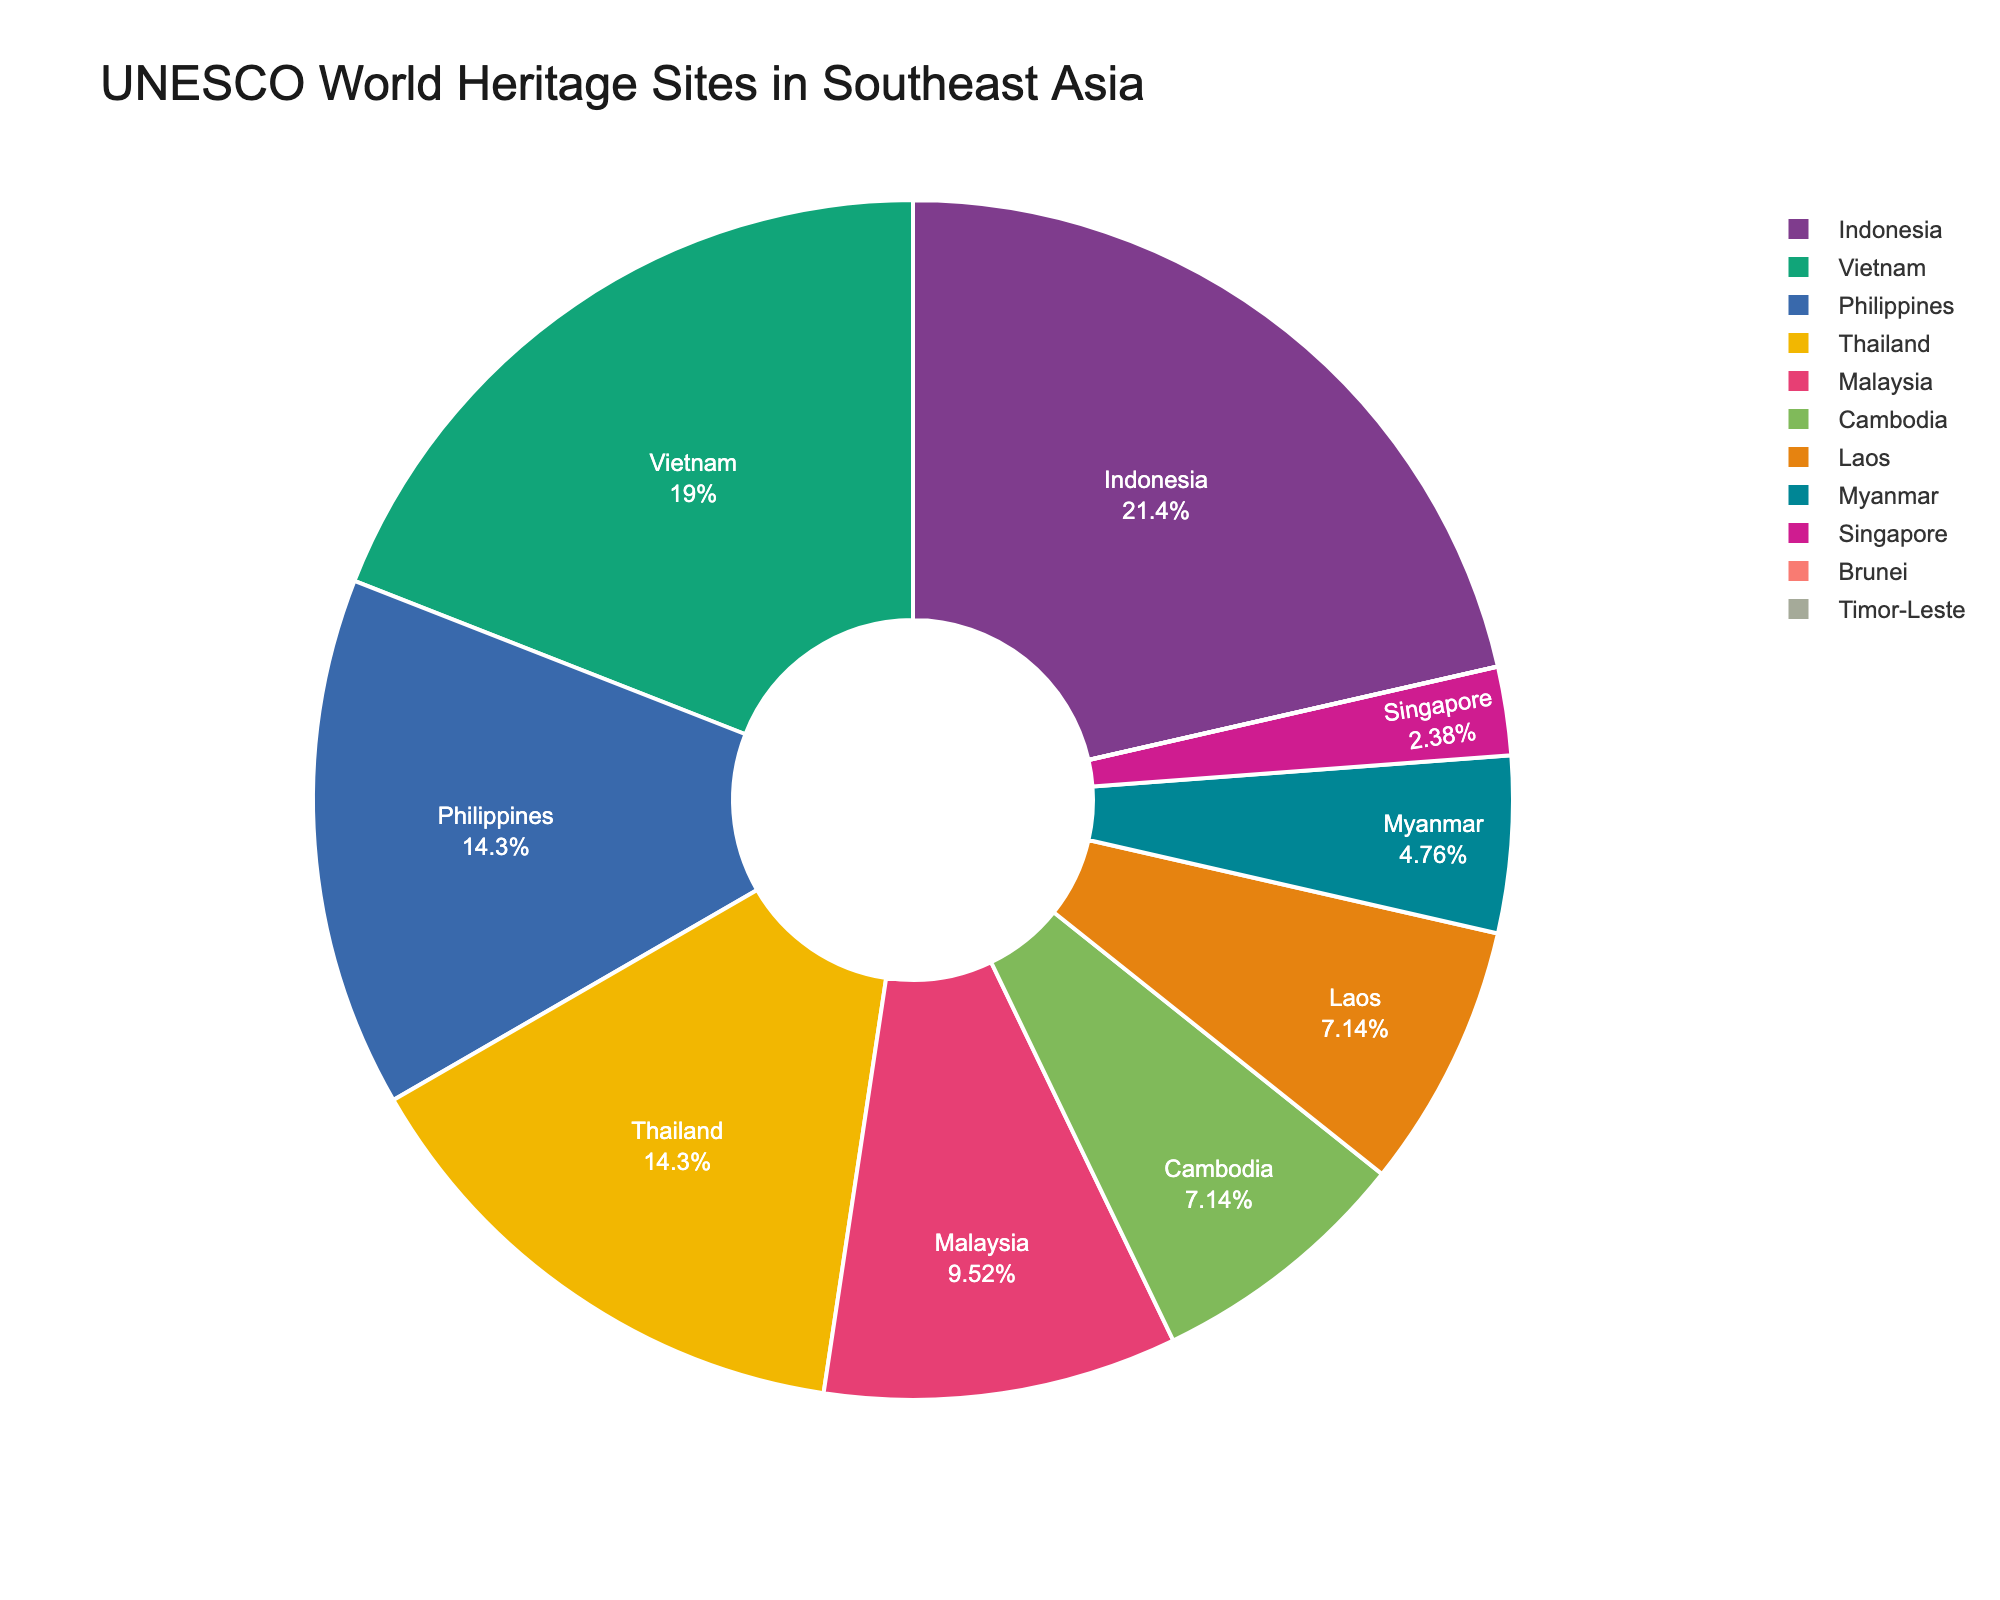What's the total number of UNESCO World Heritage Sites in Indonesia and Vietnam combined? To find the total, add the number of sites in Indonesia (9) to those in Vietnam (8). Thus, 9 + 8 = 17
Answer: 17 Which country has the most UNESCO World Heritage Sites? From the figure, Indonesia has the highest number of sites, totaling 9, which is greater than any other country listed.
Answer: Indonesia What percentage of the total UNESCO World Heritage Sites in Southeast Asia is located in Indonesia? Use the given data to find the percentage. First, calculate the total number of sites by adding the figures: 9 + 8 + 6 + 6 + 4 + 3 + 3 + 2 + 1 + 0 + 0 = 42. Then, the percentage is (9/42) * 100 ≈ 21.4%
Answer: Approximately 21.4% Is the number of UNESCO World Heritage Sites in Cambodia more than those in Myanmar? Cambodia has 3 sites compared to Myanmar’s 2 sites, so Cambodia has more sites than Myanmar.
Answer: Yes What is the difference in the number of UNESCO World Heritage Sites between the Philippines and Malaysia? Subtract the number of sites in Malaysia (4) from the number in the Philippines (6). Thus, 6 - 4 = 2
Answer: 2 What proportion of the total UNESCO World Heritage Sites do Thailand and the Philippines collectively hold? First, find the total number of sites for both countries: Thailand (6) + Philippines (6) = 12. Then, find the total number of sites in Southeast Asia: 42. The proportion is 12/42 = 2/7 ≈ 0.2857
Answer: Approximately 0.2857 Compare the number of UNESCO World Heritage Sites between Laos and Myanmar. Which country has more, and by how many? Laos has 3 sites while Myanmar has 2 sites. Therefore, Laos has 1 more site than Myanmar.
Answer: Laos by 1 Which country has the least number of UNESCO World Heritage Sites? According to the figure, Brunei and Timor-Leste each have 0 sites, which is the least.
Answer: Brunei and Timor-Leste What is the average number of UNESCO World Heritage Sites per country in Southeast Asia? Calculate the average by dividing the total number of sites (42) by the number of countries listed (11). Thus, the average is 42/11 ≈ 3.82
Answer: Approximately 3.82 